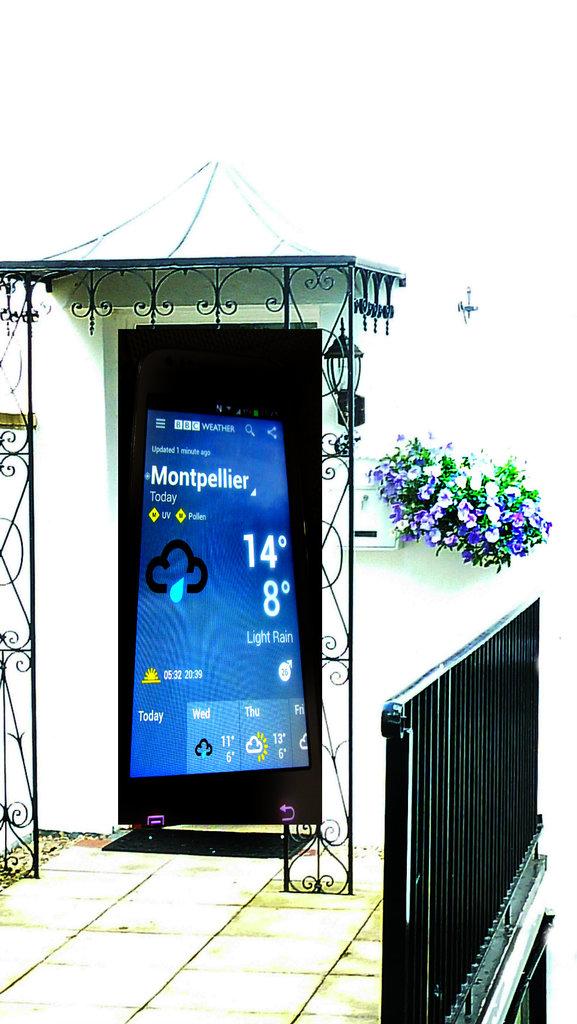What is the high tempature in montpellier?
Make the answer very short. 14. What is the degrees on the phone?
Ensure brevity in your answer.  14 and 8. 